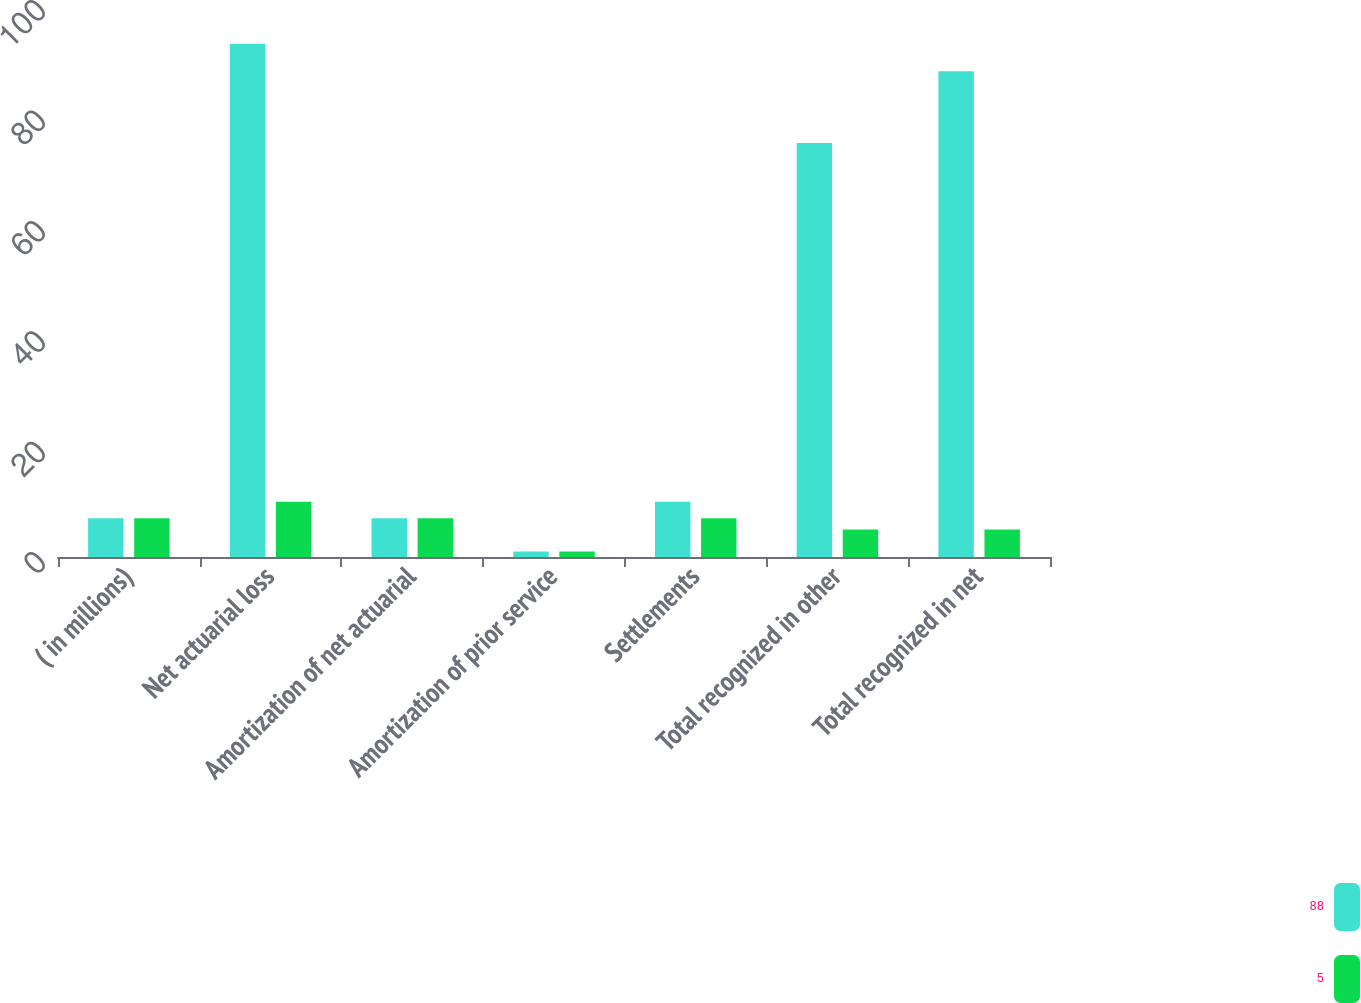<chart> <loc_0><loc_0><loc_500><loc_500><stacked_bar_chart><ecel><fcel>( in millions)<fcel>Net actuarial loss<fcel>Amortization of net actuarial<fcel>Amortization of prior service<fcel>Settlements<fcel>Total recognized in other<fcel>Total recognized in net<nl><fcel>88<fcel>7<fcel>93<fcel>7<fcel>1<fcel>10<fcel>75<fcel>88<nl><fcel>5<fcel>7<fcel>10<fcel>7<fcel>1<fcel>7<fcel>5<fcel>5<nl></chart> 